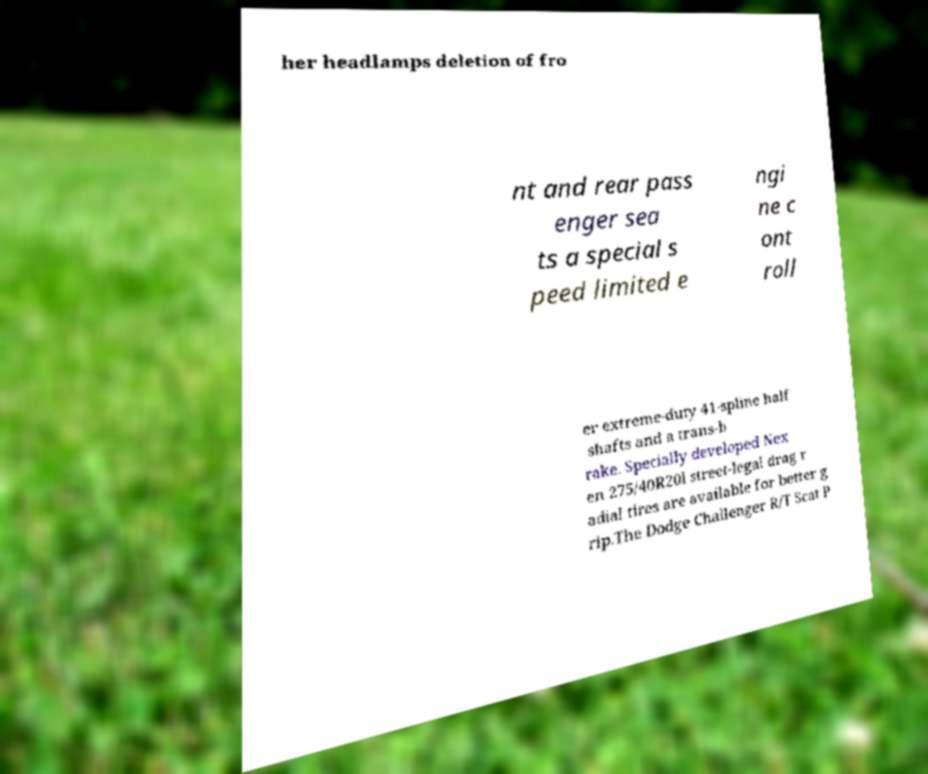There's text embedded in this image that I need extracted. Can you transcribe it verbatim? her headlamps deletion of fro nt and rear pass enger sea ts a special s peed limited e ngi ne c ont roll er extreme-duty 41-spline half shafts and a trans-b rake. Specially developed Nex en 275/40R20l street-legal drag r adial tires are available for better g rip.The Dodge Challenger R/T Scat P 